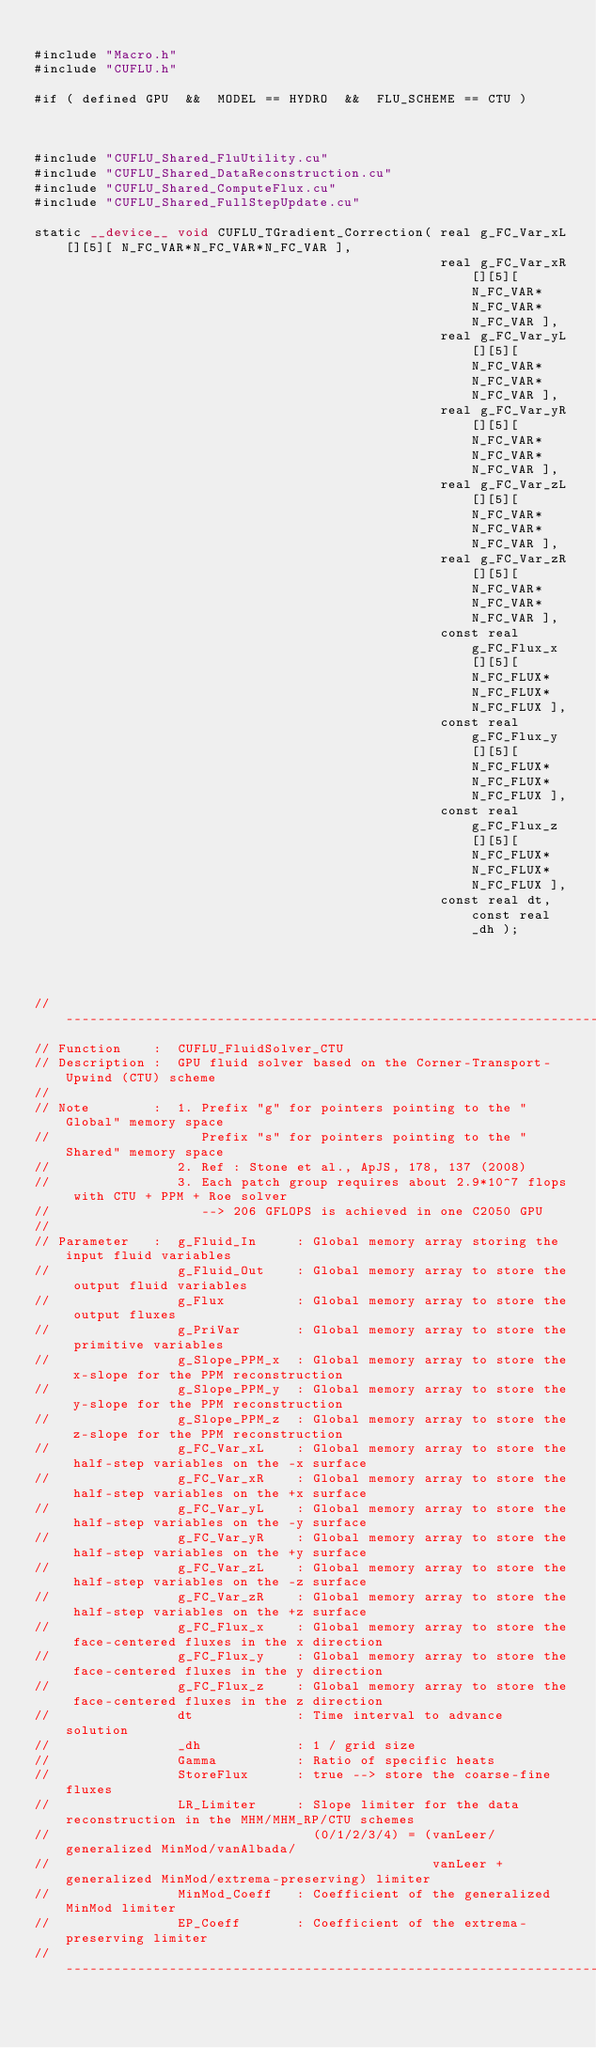<code> <loc_0><loc_0><loc_500><loc_500><_Cuda_>
#include "Macro.h"
#include "CUFLU.h"

#if ( defined GPU  &&  MODEL == HYDRO  &&  FLU_SCHEME == CTU )



#include "CUFLU_Shared_FluUtility.cu"
#include "CUFLU_Shared_DataReconstruction.cu"
#include "CUFLU_Shared_ComputeFlux.cu"
#include "CUFLU_Shared_FullStepUpdate.cu"

static __device__ void CUFLU_TGradient_Correction( real g_FC_Var_xL[][5][ N_FC_VAR*N_FC_VAR*N_FC_VAR ], 
                                                   real g_FC_Var_xR[][5][ N_FC_VAR*N_FC_VAR*N_FC_VAR ], 
                                                   real g_FC_Var_yL[][5][ N_FC_VAR*N_FC_VAR*N_FC_VAR ], 
                                                   real g_FC_Var_yR[][5][ N_FC_VAR*N_FC_VAR*N_FC_VAR ],
                                                   real g_FC_Var_zL[][5][ N_FC_VAR*N_FC_VAR*N_FC_VAR ], 
                                                   real g_FC_Var_zR[][5][ N_FC_VAR*N_FC_VAR*N_FC_VAR ],
                                                   const real g_FC_Flux_x[][5][ N_FC_FLUX*N_FC_FLUX*N_FC_FLUX ],
                                                   const real g_FC_Flux_y[][5][ N_FC_FLUX*N_FC_FLUX*N_FC_FLUX ],
                                                   const real g_FC_Flux_z[][5][ N_FC_FLUX*N_FC_FLUX*N_FC_FLUX ],
                                                   const real dt, const real _dh );




//-------------------------------------------------------------------------------------------------------
// Function    :  CUFLU_FluidSolver_CTU
// Description :  GPU fluid solver based on the Corner-Transport-Upwind (CTU) scheme
//
// Note        :  1. Prefix "g" for pointers pointing to the "Global" memory space
//                   Prefix "s" for pointers pointing to the "Shared" memory space
//                2. Ref : Stone et al., ApJS, 178, 137 (2008)
//                3. Each patch group requires about 2.9*10^7 flops with CTU + PPM + Roe solver
//                   --> 206 GFLOPS is achieved in one C2050 GPU
//
// Parameter   :  g_Fluid_In     : Global memory array storing the input fluid variables
//                g_Fluid_Out    : Global memory array to store the output fluid variables
//                g_Flux         : Global memory array to store the output fluxes
//                g_PriVar       : Global memory array to store the primitive variables
//                g_Slope_PPM_x  : Global memory array to store the x-slope for the PPM reconstruction
//                g_Slope_PPM_y  : Global memory array to store the y-slope for the PPM reconstruction
//                g_Slope_PPM_z  : Global memory array to store the z-slope for the PPM reconstruction
//                g_FC_Var_xL    : Global memory array to store the half-step variables on the -x surface
//                g_FC_Var_xR    : Global memory array to store the half-step variables on the +x surface
//                g_FC_Var_yL    : Global memory array to store the half-step variables on the -y surface
//                g_FC_Var_yR    : Global memory array to store the half-step variables on the +y surface
//                g_FC_Var_zL    : Global memory array to store the half-step variables on the -z surface
//                g_FC_Var_zR    : Global memory array to store the half-step variables on the +z surface
//                g_FC_Flux_x    : Global memory array to store the face-centered fluxes in the x direction
//                g_FC_Flux_y    : Global memory array to store the face-centered fluxes in the y direction
//                g_FC_Flux_z    : Global memory array to store the face-centered fluxes in the z direction
//                dt             : Time interval to advance solution
//                _dh            : 1 / grid size
//                Gamma          : Ratio of specific heats
//                StoreFlux      : true --> store the coarse-fine fluxes
//                LR_Limiter     : Slope limiter for the data reconstruction in the MHM/MHM_RP/CTU schemes
//                                 (0/1/2/3/4) = (vanLeer/generalized MinMod/vanAlbada/
//                                                vanLeer + generalized MinMod/extrema-preserving) limiter
//                MinMod_Coeff   : Coefficient of the generalized MinMod limiter
//                EP_Coeff       : Coefficient of the extrema-preserving limiter
//-------------------------------------------------------------------------------------------------------</code> 